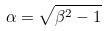Convert formula to latex. <formula><loc_0><loc_0><loc_500><loc_500>\alpha = \sqrt { \beta ^ { 2 } - 1 }</formula> 